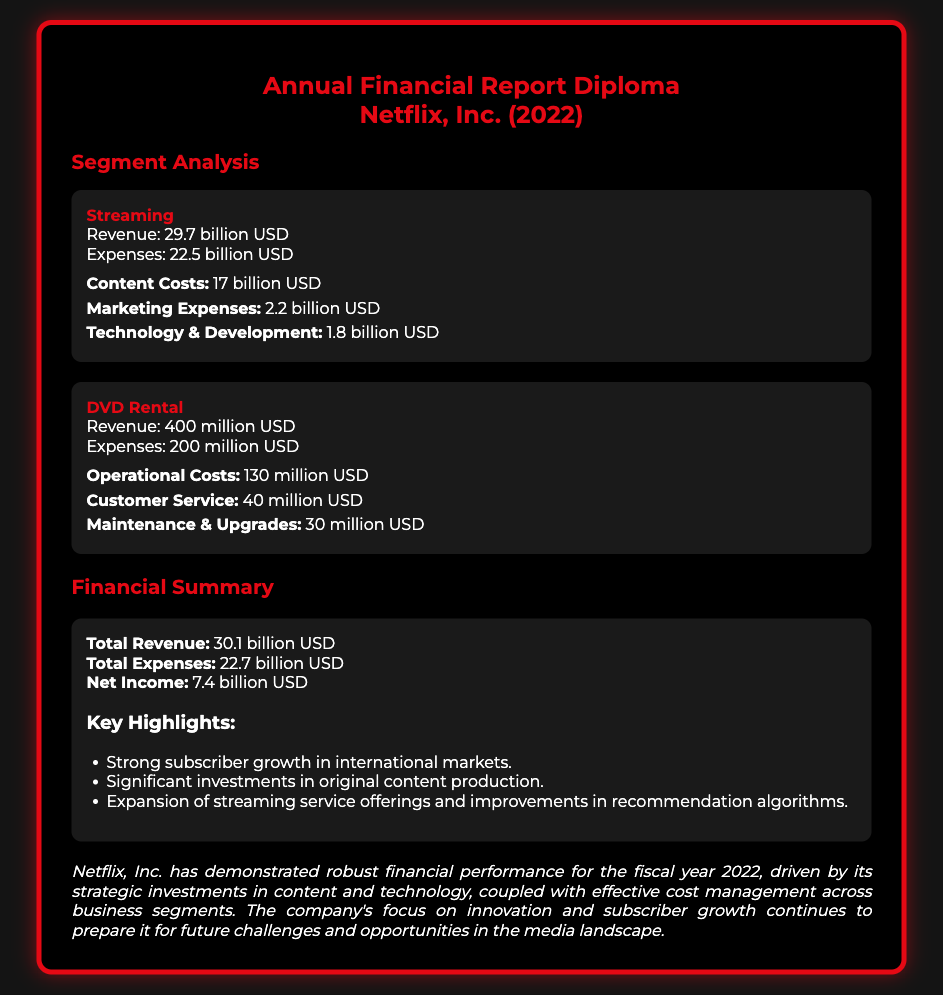What is the revenue for the Streaming segment? The revenue for the Streaming segment is explicitly stated in the document as 29.7 billion USD.
Answer: 29.7 billion USD What are the total expenses? The total expenses are calculated by summing all expenses provided in the document, which includes expenses from both segments, resulting in 22.7 billion USD.
Answer: 22.7 billion USD What is the net income reported? The net income is determined from the total revenue minus total expenses, which equals 7.4 billion USD according to the summary section.
Answer: 7.4 billion USD What amount was spent on content costs in the Streaming segment? The content costs in the Streaming segment are detailed in the document as 17 billion USD.
Answer: 17 billion USD Which segment generated 400 million USD in revenue? The document clearly identifies that the DVD Rental segment generated 400 million USD in revenue.
Answer: DVD Rental What is the expense for customer service in the DVD Rental segment? The expense for customer service is listed specifically in the DVD Rental segment details as 40 million USD.
Answer: 40 million USD What key highlight relates to subscriber growth? The document mentions strong subscriber growth in international markets as a key highlight, emphasizing its importance.
Answer: Strong subscriber growth in international markets What year does this financial report pertain to? The financial report is identified within the document, stating that it pertains to the year 2022.
Answer: 2022 What is the primary color used for headings in the document? The primary color used for headings is indicated in the CSS section, which is a shade of red (#E50914).
Answer: Red 